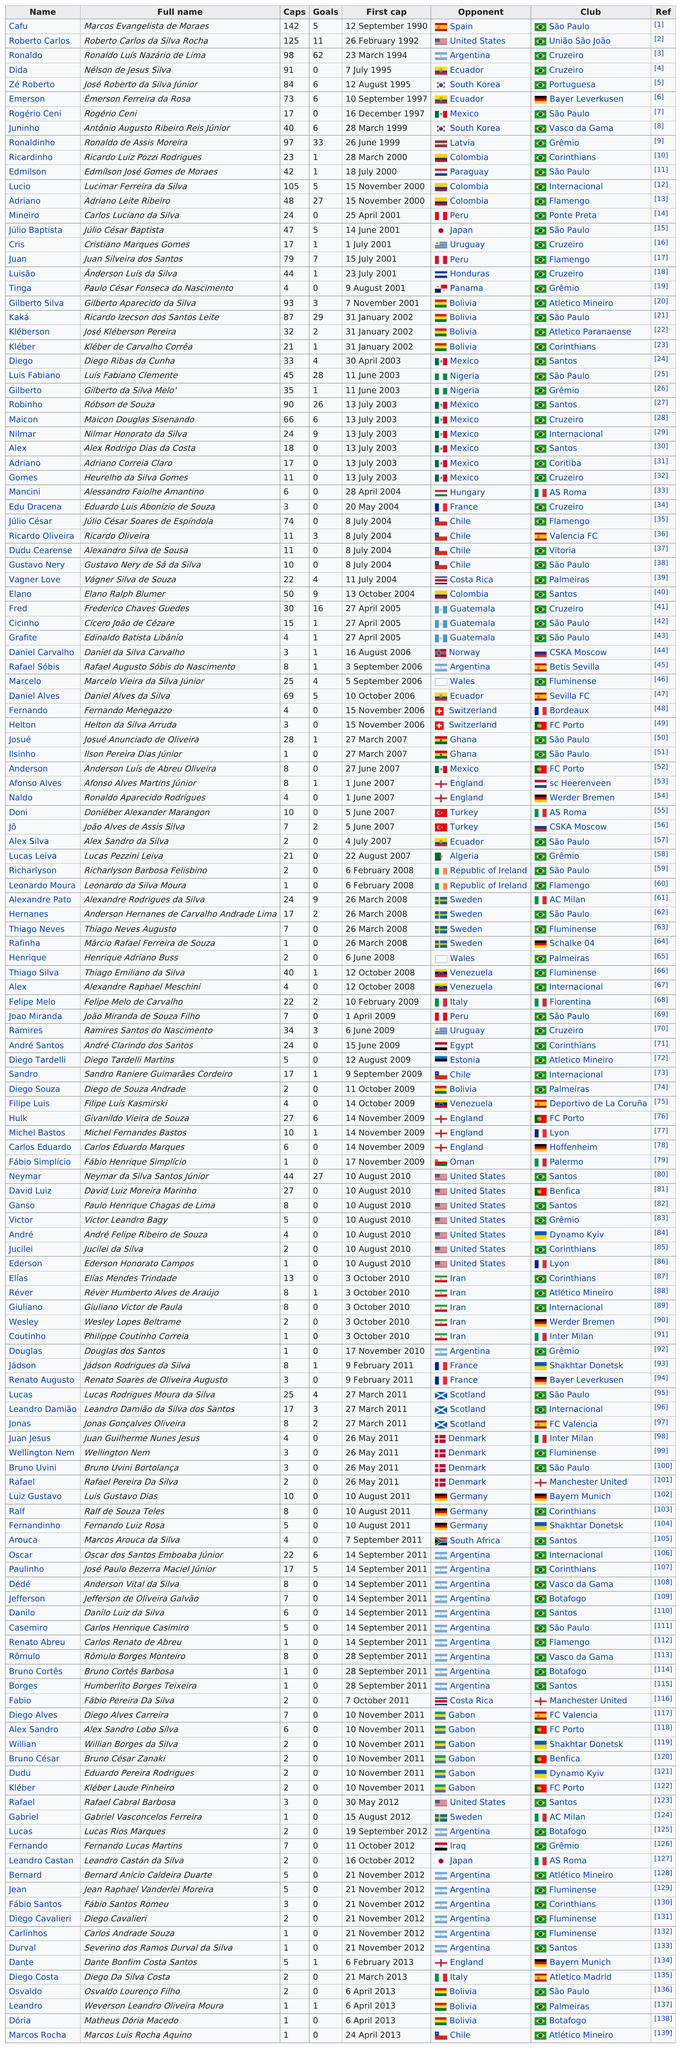Indicate a few pertinent items in this graphic. Neymar da Silva Santos Júnior, also known as Neymar Jr., scored the same number of goals as Adriano Leite Ribeiro. The United States is not considered an opponent country after August 2010, and its next listing as an opponent country is on May 30, 2012. Roberto and Emerson each scored 6 goals. Adriano Leite Ribeiro's total number of goals scored was higher against Columbia than against Lucimar Ferreira da Silva. Ninety-one players scored at least ten goals during the season. 